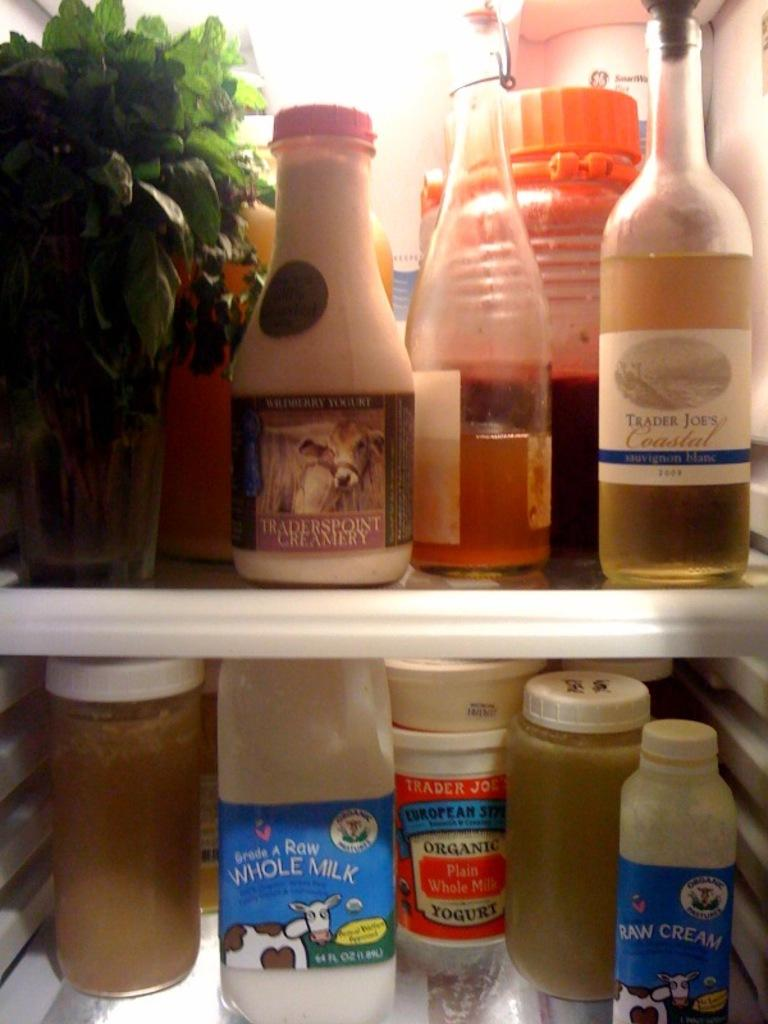Provide a one-sentence caption for the provided image. Whole milk in the refrigerator with a cow on the label. 